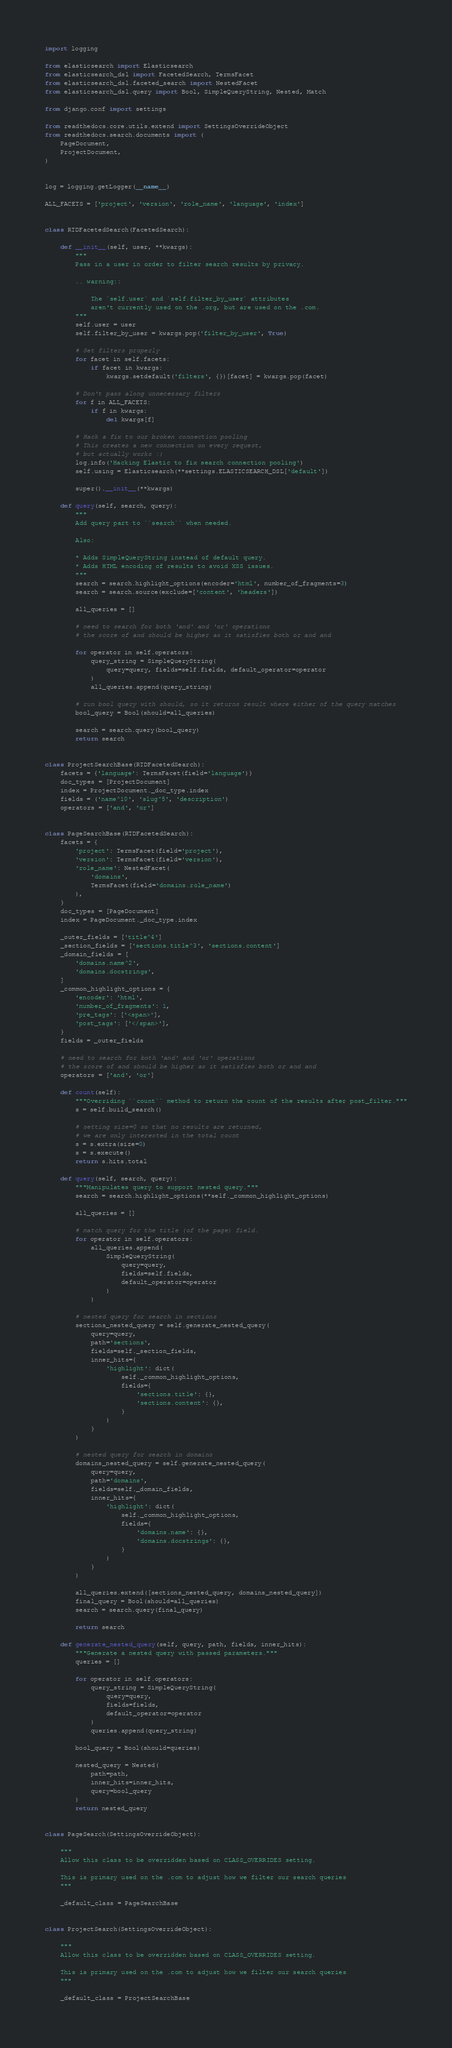<code> <loc_0><loc_0><loc_500><loc_500><_Python_>import logging

from elasticsearch import Elasticsearch
from elasticsearch_dsl import FacetedSearch, TermsFacet
from elasticsearch_dsl.faceted_search import NestedFacet
from elasticsearch_dsl.query import Bool, SimpleQueryString, Nested, Match

from django.conf import settings

from readthedocs.core.utils.extend import SettingsOverrideObject
from readthedocs.search.documents import (
    PageDocument,
    ProjectDocument,
)


log = logging.getLogger(__name__)

ALL_FACETS = ['project', 'version', 'role_name', 'language', 'index']


class RTDFacetedSearch(FacetedSearch):

    def __init__(self, user, **kwargs):
        """
        Pass in a user in order to filter search results by privacy.

        .. warning::

            The `self.user` and `self.filter_by_user` attributes
            aren't currently used on the .org, but are used on the .com.
        """
        self.user = user
        self.filter_by_user = kwargs.pop('filter_by_user', True)

        # Set filters properly
        for facet in self.facets:
            if facet in kwargs:
                kwargs.setdefault('filters', {})[facet] = kwargs.pop(facet)

        # Don't pass along unnecessary filters
        for f in ALL_FACETS:
            if f in kwargs:
                del kwargs[f]

        # Hack a fix to our broken connection pooling
        # This creates a new connection on every request,
        # but actually works :)
        log.info('Hacking Elastic to fix search connection pooling')
        self.using = Elasticsearch(**settings.ELASTICSEARCH_DSL['default'])

        super().__init__(**kwargs)

    def query(self, search, query):
        """
        Add query part to ``search`` when needed.

        Also:

        * Adds SimpleQueryString instead of default query.
        * Adds HTML encoding of results to avoid XSS issues.
        """
        search = search.highlight_options(encoder='html', number_of_fragments=3)
        search = search.source(exclude=['content', 'headers'])

        all_queries = []

        # need to search for both 'and' and 'or' operations
        # the score of and should be higher as it satisfies both or and and

        for operator in self.operators:
            query_string = SimpleQueryString(
                query=query, fields=self.fields, default_operator=operator
            )
            all_queries.append(query_string)

        # run bool query with should, so it returns result where either of the query matches
        bool_query = Bool(should=all_queries)

        search = search.query(bool_query)
        return search


class ProjectSearchBase(RTDFacetedSearch):
    facets = {'language': TermsFacet(field='language')}
    doc_types = [ProjectDocument]
    index = ProjectDocument._doc_type.index
    fields = ('name^10', 'slug^5', 'description')
    operators = ['and', 'or']


class PageSearchBase(RTDFacetedSearch):
    facets = {
        'project': TermsFacet(field='project'),
        'version': TermsFacet(field='version'),
        'role_name': NestedFacet(
            'domains',
            TermsFacet(field='domains.role_name')
        ),
    }
    doc_types = [PageDocument]
    index = PageDocument._doc_type.index

    _outer_fields = ['title^4']
    _section_fields = ['sections.title^3', 'sections.content']
    _domain_fields = [
        'domains.name^2',
        'domains.docstrings',
    ]
    _common_highlight_options = {
        'encoder': 'html',
        'number_of_fragments': 1,
        'pre_tags': ['<span>'],
        'post_tags': ['</span>'],
    }
    fields = _outer_fields

    # need to search for both 'and' and 'or' operations
    # the score of and should be higher as it satisfies both or and and
    operators = ['and', 'or']

    def count(self):
        """Overriding ``count`` method to return the count of the results after post_filter."""
        s = self.build_search()

        # setting size=0 so that no results are returned,
        # we are only interested in the total count
        s = s.extra(size=0)
        s = s.execute()
        return s.hits.total

    def query(self, search, query):
        """Manipulates query to support nested query."""
        search = search.highlight_options(**self._common_highlight_options)

        all_queries = []

        # match query for the title (of the page) field.
        for operator in self.operators:
            all_queries.append(
                SimpleQueryString(
                    query=query,
                    fields=self.fields,
                    default_operator=operator
                )
            )

        # nested query for search in sections
        sections_nested_query = self.generate_nested_query(
            query=query,
            path='sections',
            fields=self._section_fields,
            inner_hits={
                'highlight': dict(
                    self._common_highlight_options,
                    fields={
                        'sections.title': {},
                        'sections.content': {},
                    }
                )
            }
        )

        # nested query for search in domains
        domains_nested_query = self.generate_nested_query(
            query=query,
            path='domains',
            fields=self._domain_fields,
            inner_hits={
                'highlight': dict(
                    self._common_highlight_options,
                    fields={
                        'domains.name': {},
                        'domains.docstrings': {},
                    }
                )
            }
        )

        all_queries.extend([sections_nested_query, domains_nested_query])
        final_query = Bool(should=all_queries)
        search = search.query(final_query)

        return search

    def generate_nested_query(self, query, path, fields, inner_hits):
        """Generate a nested query with passed parameters."""
        queries = []

        for operator in self.operators:
            query_string = SimpleQueryString(
                query=query,
                fields=fields,
                default_operator=operator
            )
            queries.append(query_string)

        bool_query = Bool(should=queries)

        nested_query = Nested(
            path=path,
            inner_hits=inner_hits,
            query=bool_query
        )
        return nested_query


class PageSearch(SettingsOverrideObject):

    """
    Allow this class to be overridden based on CLASS_OVERRIDES setting.

    This is primary used on the .com to adjust how we filter our search queries
    """

    _default_class = PageSearchBase


class ProjectSearch(SettingsOverrideObject):

    """
    Allow this class to be overridden based on CLASS_OVERRIDES setting.

    This is primary used on the .com to adjust how we filter our search queries
    """

    _default_class = ProjectSearchBase
</code> 